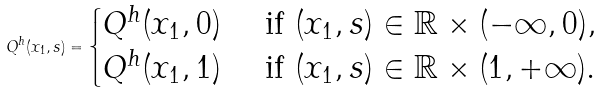Convert formula to latex. <formula><loc_0><loc_0><loc_500><loc_500>Q ^ { h } ( x _ { 1 } , s ) = \begin{cases} Q ^ { h } ( x _ { 1 } , 0 ) & \text { if } ( x _ { 1 } , s ) \in \mathbb { R } \times ( - \infty , 0 ) , \\ Q ^ { h } ( x _ { 1 } , 1 ) & \text { if } ( x _ { 1 } , s ) \in \mathbb { R } \times ( 1 , + \infty ) . \end{cases}</formula> 